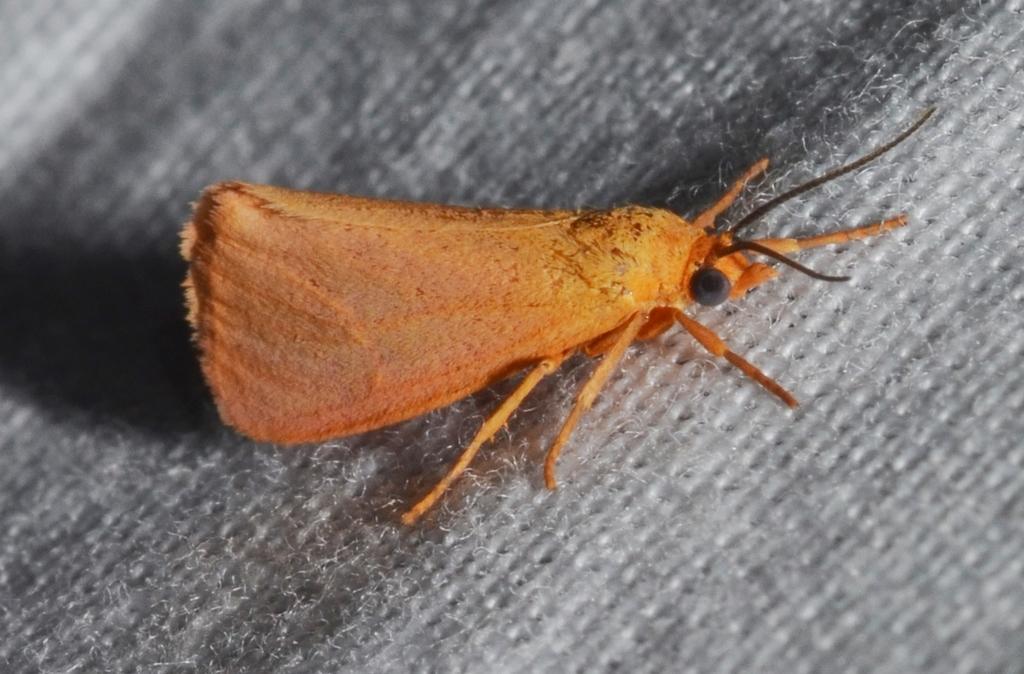Can you describe this image briefly? In this we can see an insect on a platform. 